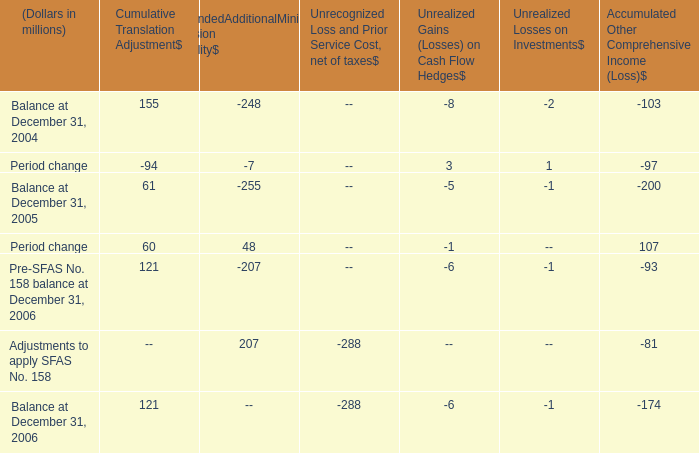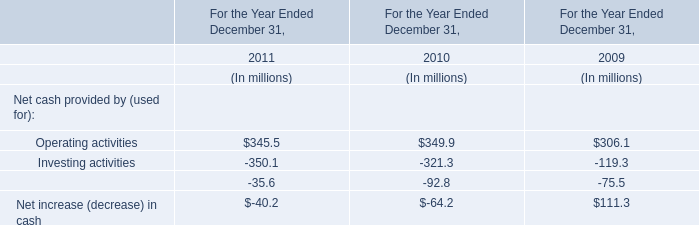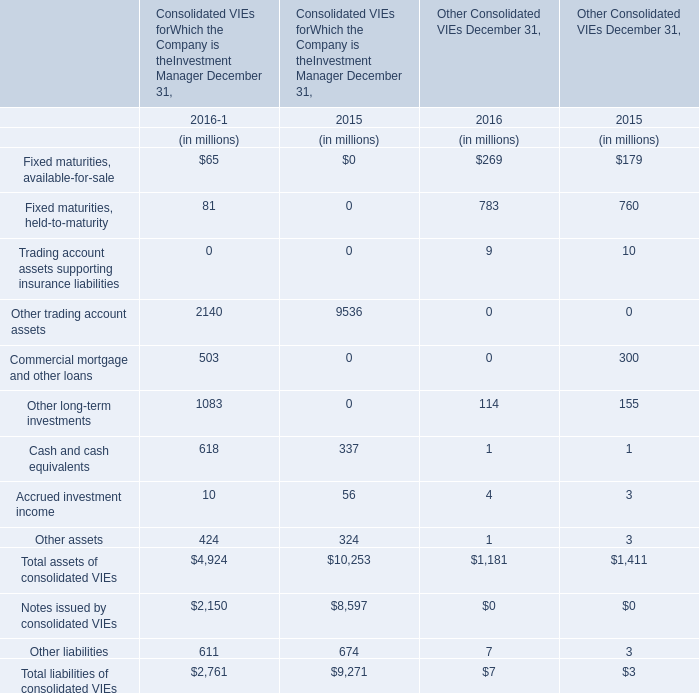what is the percent change in cumulative translation adjustment between 2005 and 2006? 
Computations: ((121 - 61) / 61)
Answer: 0.98361. 